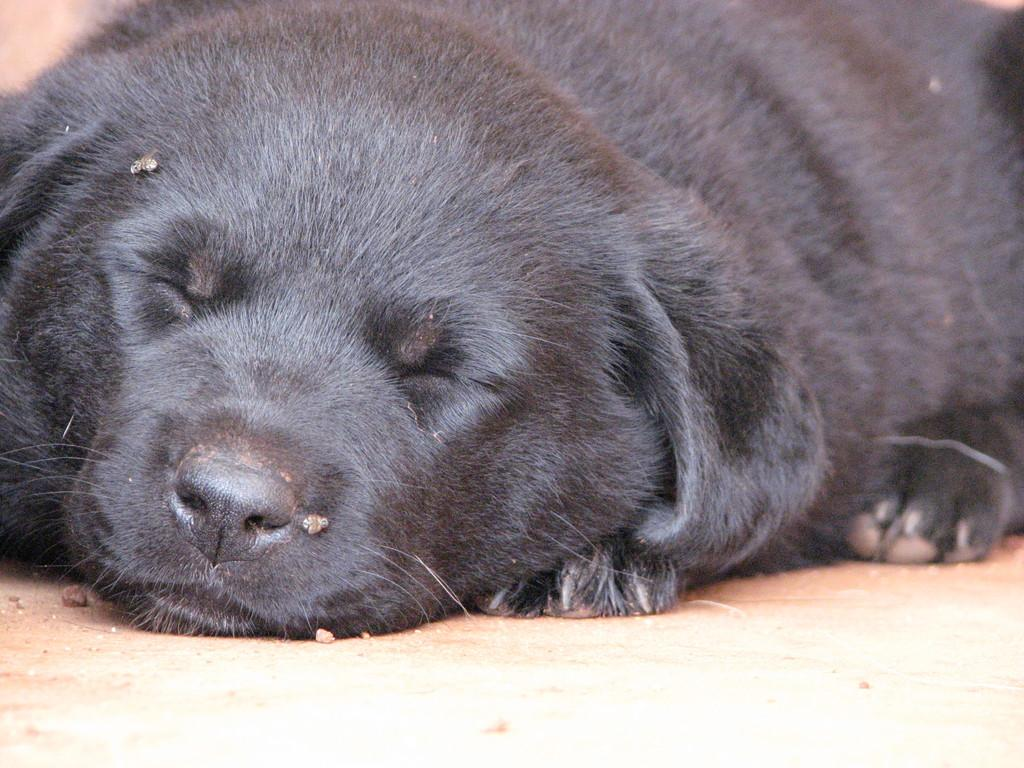What animal is present in the image? There is a dog in the picture. What is the dog doing in the image? The dog is laying on the ground. How many babies are sitting on the plate in the image? There are no babies or plates present in the image; it features a dog laying on the ground. 